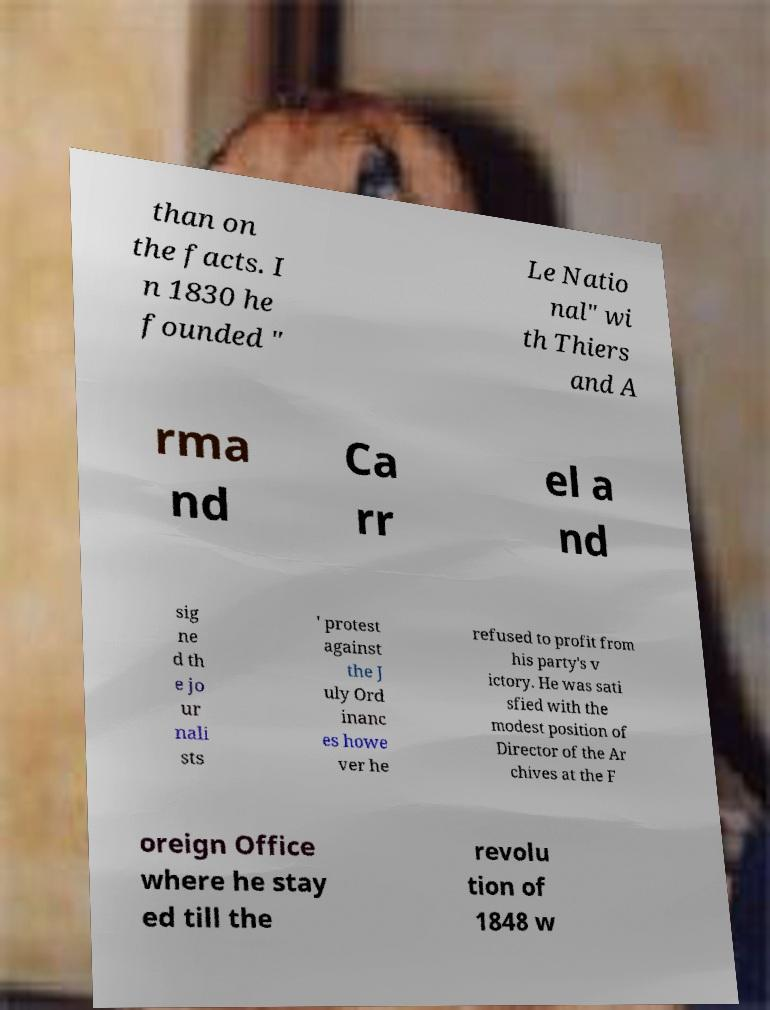Could you assist in decoding the text presented in this image and type it out clearly? than on the facts. I n 1830 he founded " Le Natio nal" wi th Thiers and A rma nd Ca rr el a nd sig ne d th e jo ur nali sts ' protest against the J uly Ord inanc es howe ver he refused to profit from his party's v ictory. He was sati sfied with the modest position of Director of the Ar chives at the F oreign Office where he stay ed till the revolu tion of 1848 w 